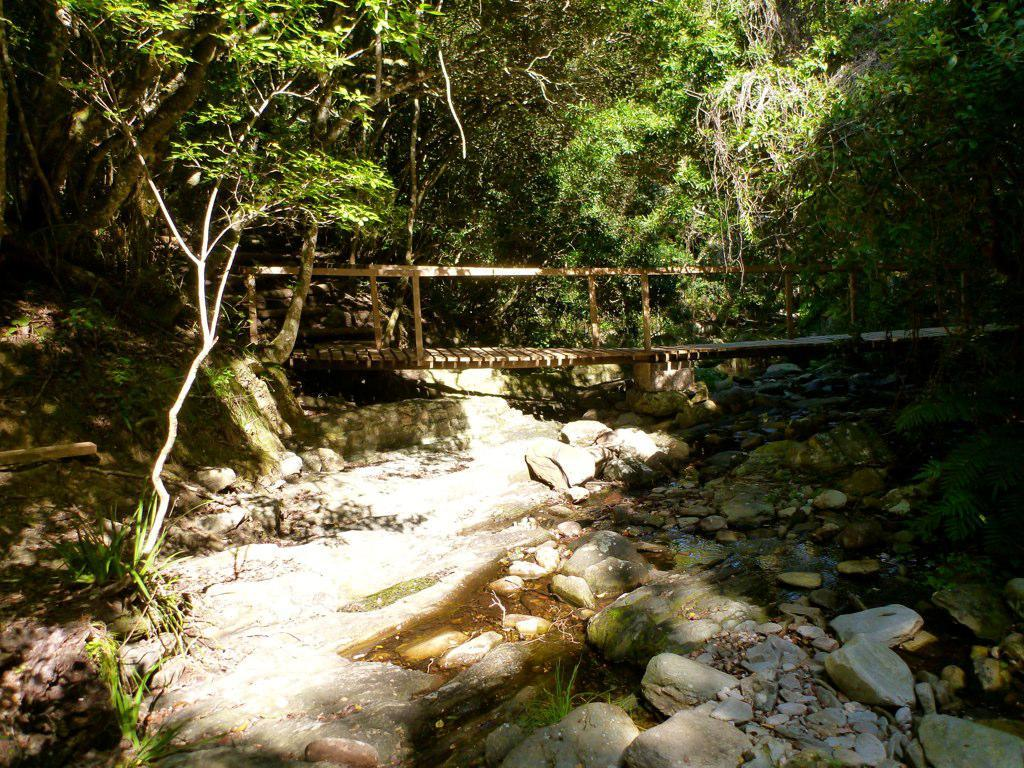What structure can be seen in the image? There is a bridge in the image. What is visible beneath the bridge? There is water flowing below the bridge. What can be found on the land near the bridge? There are rocks on the land near the bridge. What is growing on the rocks? There are plants on the rocks. What type of vegetation is near the rocks? There are trees near the rocks. Can you see a tiger tied up with a knot on the bridge in the image? No, there is no tiger or knot present in the image. 